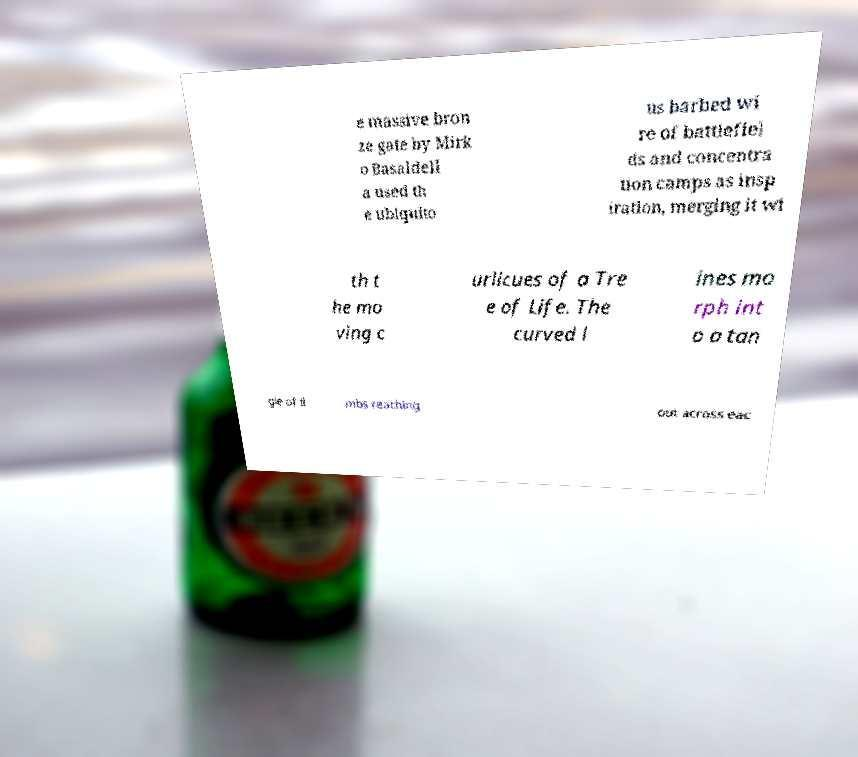I need the written content from this picture converted into text. Can you do that? e massive bron ze gate by Mirk o Basaldell a used th e ubiquito us barbed wi re of battlefiel ds and concentra tion camps as insp iration, merging it wi th t he mo ving c urlicues of a Tre e of Life. The curved l ines mo rph int o a tan gle of li mbs reaching out across eac 